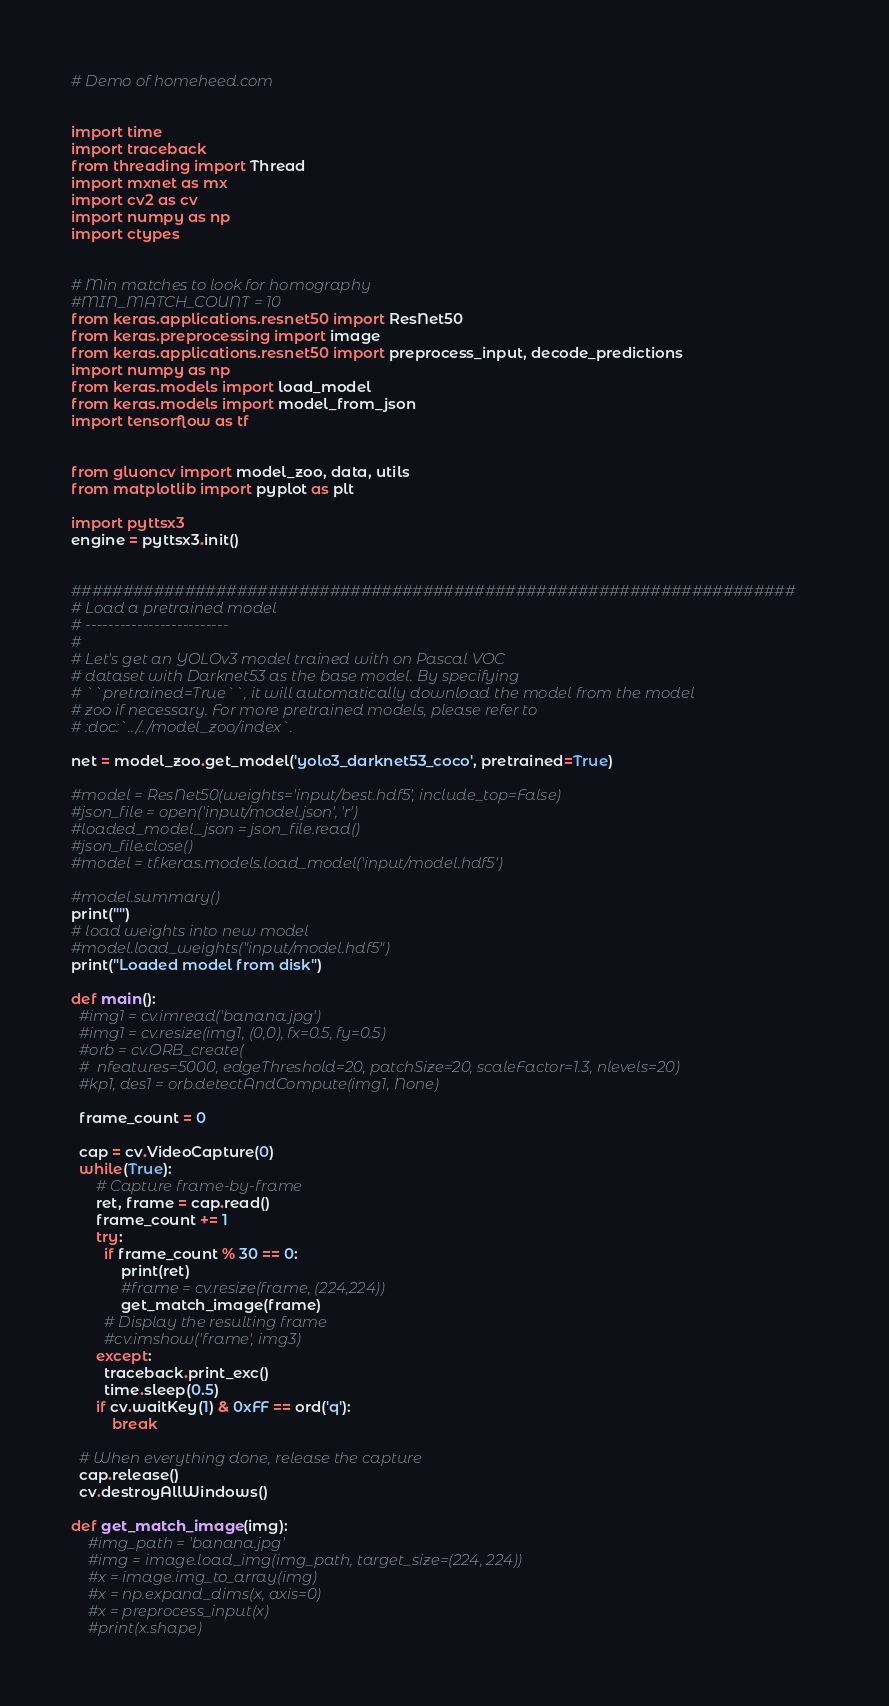<code> <loc_0><loc_0><loc_500><loc_500><_Python_># Demo of homeheed.com


import time
import traceback
from threading import Thread
import mxnet as mx
import cv2 as cv
import numpy as np
import ctypes


# Min matches to look for homography
#MIN_MATCH_COUNT = 10
from keras.applications.resnet50 import ResNet50
from keras.preprocessing import image
from keras.applications.resnet50 import preprocess_input, decode_predictions
import numpy as np
from keras.models import load_model
from keras.models import model_from_json
import tensorflow as tf


from gluoncv import model_zoo, data, utils
from matplotlib import pyplot as plt

import pyttsx3
engine = pyttsx3.init()


######################################################################
# Load a pretrained model
# -------------------------
#
# Let's get an YOLOv3 model trained with on Pascal VOC
# dataset with Darknet53 as the base model. By specifying
# ``pretrained=True``, it will automatically download the model from the model
# zoo if necessary. For more pretrained models, please refer to
# :doc:`../../model_zoo/index`.

net = model_zoo.get_model('yolo3_darknet53_coco', pretrained=True)

#model = ResNet50(weights='input/best.hdf5', include_top=False)
#json_file = open('input/model.json', 'r')
#loaded_model_json = json_file.read()
#json_file.close()
#model = tf.keras.models.load_model('input/model.hdf5')

#model.summary()
print("")
# load weights into new model
#model.load_weights("input/model.hdf5")
print("Loaded model from disk")

def main():
  #img1 = cv.imread('banana.jpg')
  #img1 = cv.resize(img1, (0,0), fx=0.5, fy=0.5)
  #orb = cv.ORB_create(
  #  nfeatures=5000, edgeThreshold=20, patchSize=20, scaleFactor=1.3, nlevels=20)
  #kp1, des1 = orb.detectAndCompute(img1, None)

  frame_count = 0
  
  cap = cv.VideoCapture(0)
  while(True):
      # Capture frame-by-frame
      ret, frame = cap.read()
      frame_count += 1
      try:
        if frame_count % 30 == 0:
            print(ret)
            #frame = cv.resize(frame, (224,224))
            get_match_image(frame)
        # Display the resulting frame
        #cv.imshow('frame', img3)
      except:
        traceback.print_exc()
        time.sleep(0.5)
      if cv.waitKey(1) & 0xFF == ord('q'):
          break

  # When everything done, release the capture
  cap.release()
  cv.destroyAllWindows()

def get_match_image(img):
    #img_path = 'banana.jpg'
    #img = image.load_img(img_path, target_size=(224, 224))
    #x = image.img_to_array(img)
    #x = np.expand_dims(x, axis=0)
    #x = preprocess_input(x)
    #print(x.shape)</code> 